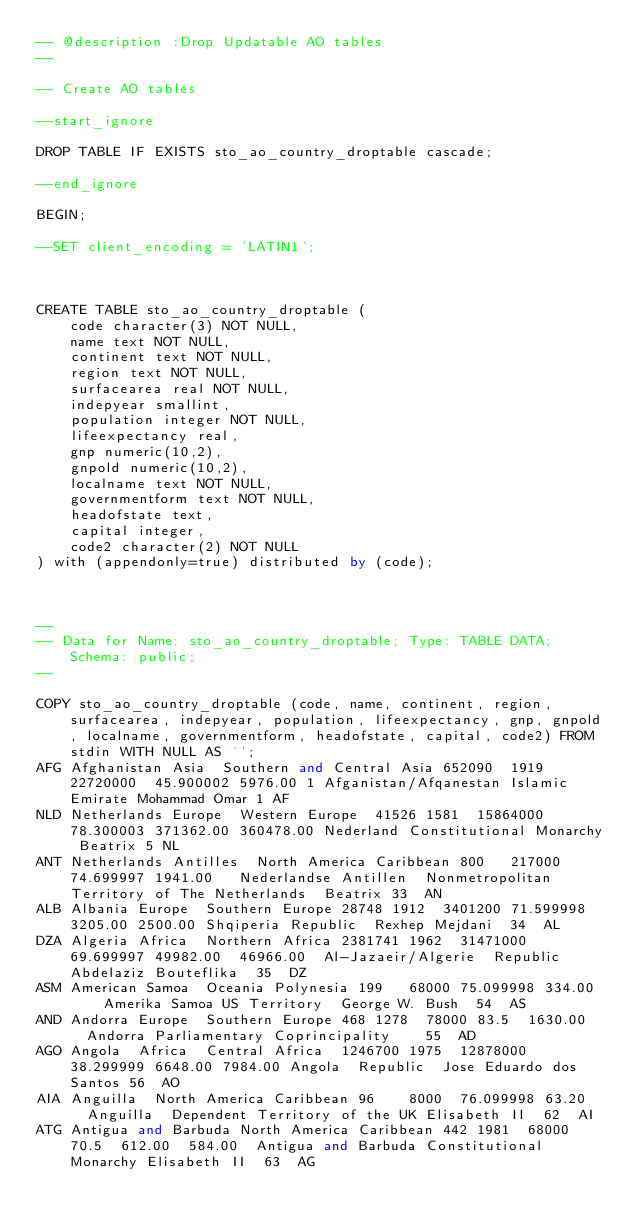Convert code to text. <code><loc_0><loc_0><loc_500><loc_500><_SQL_>-- @description :Drop Updatable AO tables
-- 

-- Create AO tables

--start_ignore

DROP TABLE IF EXISTS sto_ao_country_droptable cascade;

--end_ignore

BEGIN;

--SET client_encoding = 'LATIN1';



CREATE TABLE sto_ao_country_droptable (
    code character(3) NOT NULL,
    name text NOT NULL,
    continent text NOT NULL,
    region text NOT NULL,
    surfacearea real NOT NULL,
    indepyear smallint,
    population integer NOT NULL,
    lifeexpectancy real,
    gnp numeric(10,2),
    gnpold numeric(10,2),
    localname text NOT NULL,
    governmentform text NOT NULL,
    headofstate text,
    capital integer,
    code2 character(2) NOT NULL
) with (appendonly=true) distributed by (code);



--
-- Data for Name: sto_ao_country_droptable; Type: TABLE DATA; Schema: public; 
--

COPY sto_ao_country_droptable (code, name, continent, region, surfacearea, indepyear, population, lifeexpectancy, gnp, gnpold, localname, governmentform, headofstate, capital, code2) FROM stdin WITH NULL AS '';
AFG	Afghanistan	Asia	Southern and Central Asia	652090	1919	22720000	45.900002	5976.00	1	Afganistan/Afqanestan	Islamic Emirate	Mohammad Omar	1	AF
NLD	Netherlands	Europe	Western Europe	41526	1581	15864000	78.300003	371362.00	360478.00	Nederland	Constitutional Monarchy	Beatrix	5	NL
ANT	Netherlands Antilles	North America	Caribbean	800		217000	74.699997	1941.00		Nederlandse Antillen	Nonmetropolitan Territory of The Netherlands	Beatrix	33	AN
ALB	Albania	Europe	Southern Europe	28748	1912	3401200	71.599998	3205.00	2500.00	Shqiperia	Republic	Rexhep Mejdani	34	AL
DZA	Algeria	Africa	Northern Africa	2381741	1962	31471000	69.699997	49982.00	46966.00	Al-Jazaeir/Algerie	Republic	Abdelaziz Bouteflika	35	DZ
ASM	American Samoa	Oceania	Polynesia	199		68000	75.099998	334.00		Amerika Samoa	US Territory	George W. Bush	54	AS
AND	Andorra	Europe	Southern Europe	468	1278	78000	83.5	1630.00		Andorra	Parliamentary Coprincipality		55	AD
AGO	Angola	Africa	Central Africa	1246700	1975	12878000	38.299999	6648.00	7984.00	Angola	Republic	Jose Eduardo dos Santos	56	AO
AIA	Anguilla	North America	Caribbean	96		8000	76.099998	63.20		Anguilla	Dependent Territory of the UK	Elisabeth II	62	AI
ATG	Antigua and Barbuda	North America	Caribbean	442	1981	68000	70.5	612.00	584.00	Antigua and Barbuda	Constitutional Monarchy	Elisabeth II	63	AG</code> 